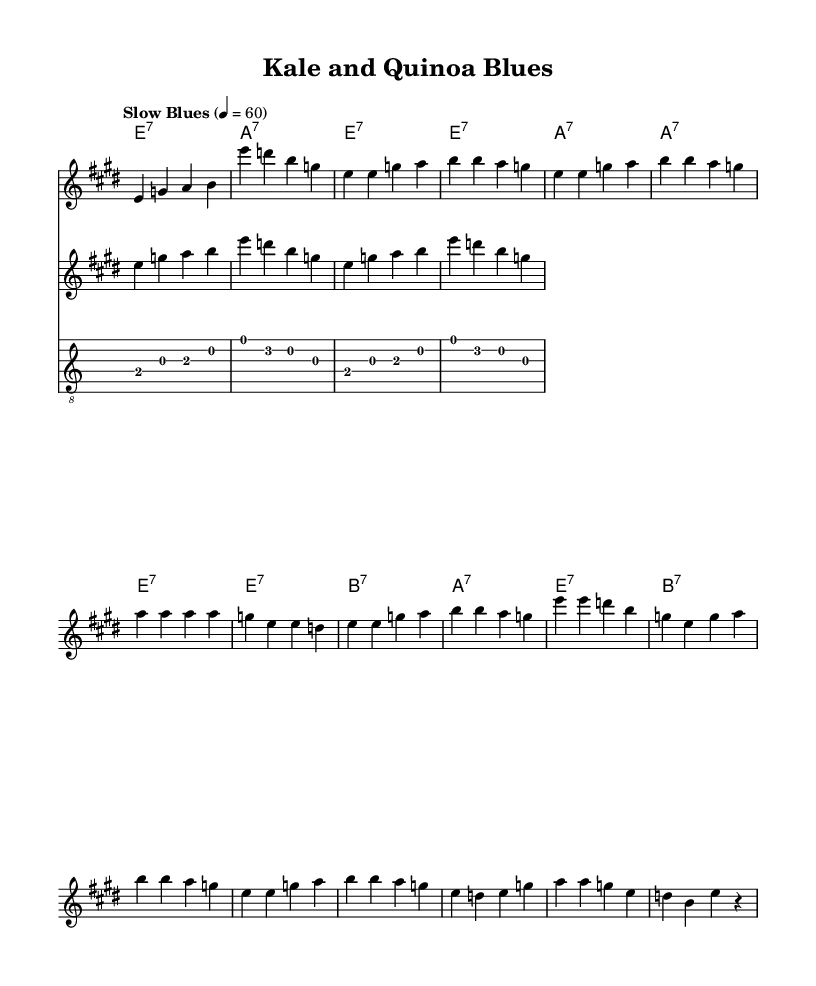What is the key signature of this music? The key signature is E major, which has four sharps (F#, C#, G#, and D#). This is determined by looking at the key indicated at the beginning of the score.
Answer: E major What is the time signature of this music? The time signature is four-four time, indicated by the notation at the beginning of the score. It shows that there are four beats in each measure, and the quarter note gets one beat.
Answer: Four-four What is the tempo marking for this piece? The tempo marking is "Slow Blues" with a metronome setting of 60 beats per minute. This is found in the tempo indication at the beginning of the music.
Answer: Slow Blues What are the main chords used in this piece? The main chords in the piece are E7, A7, and B7. This can be observed in the chord names section, where these chords are listed throughout the score.
Answer: E7, A7, B7 How many bars are there in the chorus section? The chorus section consists of four bars, as indicated by the layout of the music notation where the chorus lyrics align with the measured musical phrases.
Answer: Four Which section includes the lyrics about "eating clean"? The lyrics about "eating clean" can be found in the verse section of the music, where specific lines refer to the transition from junk food to a healthier diet.
Answer: Verse What is the structure of the piece based on the sections provided? The structure of the piece follows a classic blues format consisting of a verse followed by a chorus, and this pattern repeats. This can be seen by analyzing the organization of the lyrics and melody throughout the score.
Answer: Verse-Chorus 